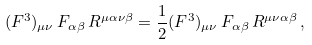<formula> <loc_0><loc_0><loc_500><loc_500>( F ^ { 3 } ) _ { \mu \nu } \, F _ { \alpha \beta } \, R ^ { \mu \alpha \nu \beta } = \frac { 1 } { 2 } ( F ^ { 3 } ) _ { \mu \nu } \, F _ { \alpha \beta } \, R ^ { \mu \nu \alpha \beta } \, ,</formula> 